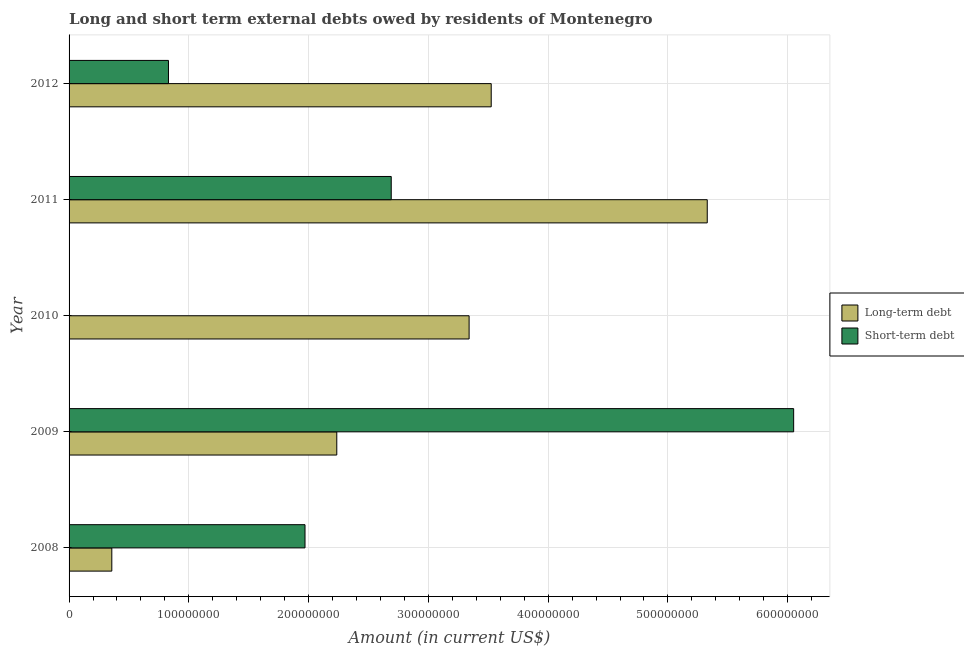How many different coloured bars are there?
Your response must be concise. 2. Are the number of bars per tick equal to the number of legend labels?
Your answer should be very brief. No. How many bars are there on the 1st tick from the top?
Your answer should be very brief. 2. How many bars are there on the 4th tick from the bottom?
Keep it short and to the point. 2. In how many cases, is the number of bars for a given year not equal to the number of legend labels?
Give a very brief answer. 1. What is the long-term debts owed by residents in 2009?
Ensure brevity in your answer.  2.24e+08. Across all years, what is the maximum short-term debts owed by residents?
Give a very brief answer. 6.05e+08. Across all years, what is the minimum long-term debts owed by residents?
Offer a very short reply. 3.57e+07. In which year was the long-term debts owed by residents maximum?
Offer a terse response. 2011. What is the total long-term debts owed by residents in the graph?
Offer a terse response. 1.48e+09. What is the difference between the short-term debts owed by residents in 2011 and that in 2012?
Your answer should be very brief. 1.86e+08. What is the difference between the long-term debts owed by residents in 2011 and the short-term debts owed by residents in 2010?
Give a very brief answer. 5.33e+08. What is the average short-term debts owed by residents per year?
Offer a very short reply. 2.31e+08. In the year 2012, what is the difference between the short-term debts owed by residents and long-term debts owed by residents?
Give a very brief answer. -2.69e+08. In how many years, is the short-term debts owed by residents greater than 420000000 US$?
Your answer should be very brief. 1. What is the ratio of the long-term debts owed by residents in 2008 to that in 2012?
Offer a very short reply. 0.1. What is the difference between the highest and the second highest long-term debts owed by residents?
Make the answer very short. 1.80e+08. What is the difference between the highest and the lowest short-term debts owed by residents?
Make the answer very short. 6.05e+08. How many bars are there?
Offer a very short reply. 9. What is the difference between two consecutive major ticks on the X-axis?
Give a very brief answer. 1.00e+08. Are the values on the major ticks of X-axis written in scientific E-notation?
Give a very brief answer. No. Does the graph contain grids?
Your answer should be very brief. Yes. Where does the legend appear in the graph?
Offer a very short reply. Center right. How many legend labels are there?
Provide a succinct answer. 2. What is the title of the graph?
Your response must be concise. Long and short term external debts owed by residents of Montenegro. Does "Foreign Liabilities" appear as one of the legend labels in the graph?
Ensure brevity in your answer.  No. What is the Amount (in current US$) in Long-term debt in 2008?
Ensure brevity in your answer.  3.57e+07. What is the Amount (in current US$) in Short-term debt in 2008?
Your answer should be very brief. 1.97e+08. What is the Amount (in current US$) in Long-term debt in 2009?
Provide a succinct answer. 2.24e+08. What is the Amount (in current US$) in Short-term debt in 2009?
Offer a very short reply. 6.05e+08. What is the Amount (in current US$) of Long-term debt in 2010?
Make the answer very short. 3.34e+08. What is the Amount (in current US$) of Long-term debt in 2011?
Keep it short and to the point. 5.33e+08. What is the Amount (in current US$) in Short-term debt in 2011?
Your answer should be compact. 2.69e+08. What is the Amount (in current US$) of Long-term debt in 2012?
Your answer should be very brief. 3.52e+08. What is the Amount (in current US$) in Short-term debt in 2012?
Give a very brief answer. 8.30e+07. Across all years, what is the maximum Amount (in current US$) of Long-term debt?
Your answer should be compact. 5.33e+08. Across all years, what is the maximum Amount (in current US$) in Short-term debt?
Give a very brief answer. 6.05e+08. Across all years, what is the minimum Amount (in current US$) in Long-term debt?
Your answer should be compact. 3.57e+07. What is the total Amount (in current US$) in Long-term debt in the graph?
Your answer should be very brief. 1.48e+09. What is the total Amount (in current US$) in Short-term debt in the graph?
Your response must be concise. 1.15e+09. What is the difference between the Amount (in current US$) of Long-term debt in 2008 and that in 2009?
Your answer should be compact. -1.88e+08. What is the difference between the Amount (in current US$) of Short-term debt in 2008 and that in 2009?
Offer a very short reply. -4.08e+08. What is the difference between the Amount (in current US$) in Long-term debt in 2008 and that in 2010?
Provide a short and direct response. -2.98e+08. What is the difference between the Amount (in current US$) of Long-term debt in 2008 and that in 2011?
Your answer should be compact. -4.97e+08. What is the difference between the Amount (in current US$) of Short-term debt in 2008 and that in 2011?
Your response must be concise. -7.20e+07. What is the difference between the Amount (in current US$) in Long-term debt in 2008 and that in 2012?
Give a very brief answer. -3.17e+08. What is the difference between the Amount (in current US$) of Short-term debt in 2008 and that in 2012?
Ensure brevity in your answer.  1.14e+08. What is the difference between the Amount (in current US$) of Long-term debt in 2009 and that in 2010?
Provide a succinct answer. -1.10e+08. What is the difference between the Amount (in current US$) of Long-term debt in 2009 and that in 2011?
Provide a succinct answer. -3.09e+08. What is the difference between the Amount (in current US$) in Short-term debt in 2009 and that in 2011?
Offer a very short reply. 3.36e+08. What is the difference between the Amount (in current US$) in Long-term debt in 2009 and that in 2012?
Provide a short and direct response. -1.29e+08. What is the difference between the Amount (in current US$) in Short-term debt in 2009 and that in 2012?
Offer a terse response. 5.22e+08. What is the difference between the Amount (in current US$) of Long-term debt in 2010 and that in 2011?
Provide a succinct answer. -1.99e+08. What is the difference between the Amount (in current US$) in Long-term debt in 2010 and that in 2012?
Your response must be concise. -1.85e+07. What is the difference between the Amount (in current US$) of Long-term debt in 2011 and that in 2012?
Give a very brief answer. 1.80e+08. What is the difference between the Amount (in current US$) of Short-term debt in 2011 and that in 2012?
Provide a succinct answer. 1.86e+08. What is the difference between the Amount (in current US$) in Long-term debt in 2008 and the Amount (in current US$) in Short-term debt in 2009?
Provide a succinct answer. -5.69e+08. What is the difference between the Amount (in current US$) of Long-term debt in 2008 and the Amount (in current US$) of Short-term debt in 2011?
Make the answer very short. -2.33e+08. What is the difference between the Amount (in current US$) of Long-term debt in 2008 and the Amount (in current US$) of Short-term debt in 2012?
Your response must be concise. -4.73e+07. What is the difference between the Amount (in current US$) in Long-term debt in 2009 and the Amount (in current US$) in Short-term debt in 2011?
Ensure brevity in your answer.  -4.55e+07. What is the difference between the Amount (in current US$) in Long-term debt in 2009 and the Amount (in current US$) in Short-term debt in 2012?
Give a very brief answer. 1.41e+08. What is the difference between the Amount (in current US$) in Long-term debt in 2010 and the Amount (in current US$) in Short-term debt in 2011?
Provide a succinct answer. 6.50e+07. What is the difference between the Amount (in current US$) in Long-term debt in 2010 and the Amount (in current US$) in Short-term debt in 2012?
Ensure brevity in your answer.  2.51e+08. What is the difference between the Amount (in current US$) in Long-term debt in 2011 and the Amount (in current US$) in Short-term debt in 2012?
Offer a very short reply. 4.50e+08. What is the average Amount (in current US$) in Long-term debt per year?
Your response must be concise. 2.96e+08. What is the average Amount (in current US$) of Short-term debt per year?
Provide a short and direct response. 2.31e+08. In the year 2008, what is the difference between the Amount (in current US$) of Long-term debt and Amount (in current US$) of Short-term debt?
Ensure brevity in your answer.  -1.61e+08. In the year 2009, what is the difference between the Amount (in current US$) of Long-term debt and Amount (in current US$) of Short-term debt?
Your answer should be compact. -3.81e+08. In the year 2011, what is the difference between the Amount (in current US$) in Long-term debt and Amount (in current US$) in Short-term debt?
Your answer should be very brief. 2.64e+08. In the year 2012, what is the difference between the Amount (in current US$) in Long-term debt and Amount (in current US$) in Short-term debt?
Provide a succinct answer. 2.69e+08. What is the ratio of the Amount (in current US$) of Long-term debt in 2008 to that in 2009?
Your response must be concise. 0.16. What is the ratio of the Amount (in current US$) of Short-term debt in 2008 to that in 2009?
Offer a very short reply. 0.33. What is the ratio of the Amount (in current US$) in Long-term debt in 2008 to that in 2010?
Keep it short and to the point. 0.11. What is the ratio of the Amount (in current US$) in Long-term debt in 2008 to that in 2011?
Keep it short and to the point. 0.07. What is the ratio of the Amount (in current US$) of Short-term debt in 2008 to that in 2011?
Your response must be concise. 0.73. What is the ratio of the Amount (in current US$) in Long-term debt in 2008 to that in 2012?
Offer a very short reply. 0.1. What is the ratio of the Amount (in current US$) in Short-term debt in 2008 to that in 2012?
Offer a very short reply. 2.37. What is the ratio of the Amount (in current US$) of Long-term debt in 2009 to that in 2010?
Your answer should be very brief. 0.67. What is the ratio of the Amount (in current US$) in Long-term debt in 2009 to that in 2011?
Make the answer very short. 0.42. What is the ratio of the Amount (in current US$) in Short-term debt in 2009 to that in 2011?
Provide a succinct answer. 2.25. What is the ratio of the Amount (in current US$) in Long-term debt in 2009 to that in 2012?
Your answer should be very brief. 0.63. What is the ratio of the Amount (in current US$) of Short-term debt in 2009 to that in 2012?
Give a very brief answer. 7.29. What is the ratio of the Amount (in current US$) in Long-term debt in 2010 to that in 2011?
Give a very brief answer. 0.63. What is the ratio of the Amount (in current US$) of Long-term debt in 2010 to that in 2012?
Provide a short and direct response. 0.95. What is the ratio of the Amount (in current US$) in Long-term debt in 2011 to that in 2012?
Provide a short and direct response. 1.51. What is the ratio of the Amount (in current US$) in Short-term debt in 2011 to that in 2012?
Your response must be concise. 3.24. What is the difference between the highest and the second highest Amount (in current US$) in Long-term debt?
Offer a terse response. 1.80e+08. What is the difference between the highest and the second highest Amount (in current US$) of Short-term debt?
Your answer should be very brief. 3.36e+08. What is the difference between the highest and the lowest Amount (in current US$) in Long-term debt?
Offer a terse response. 4.97e+08. What is the difference between the highest and the lowest Amount (in current US$) of Short-term debt?
Ensure brevity in your answer.  6.05e+08. 